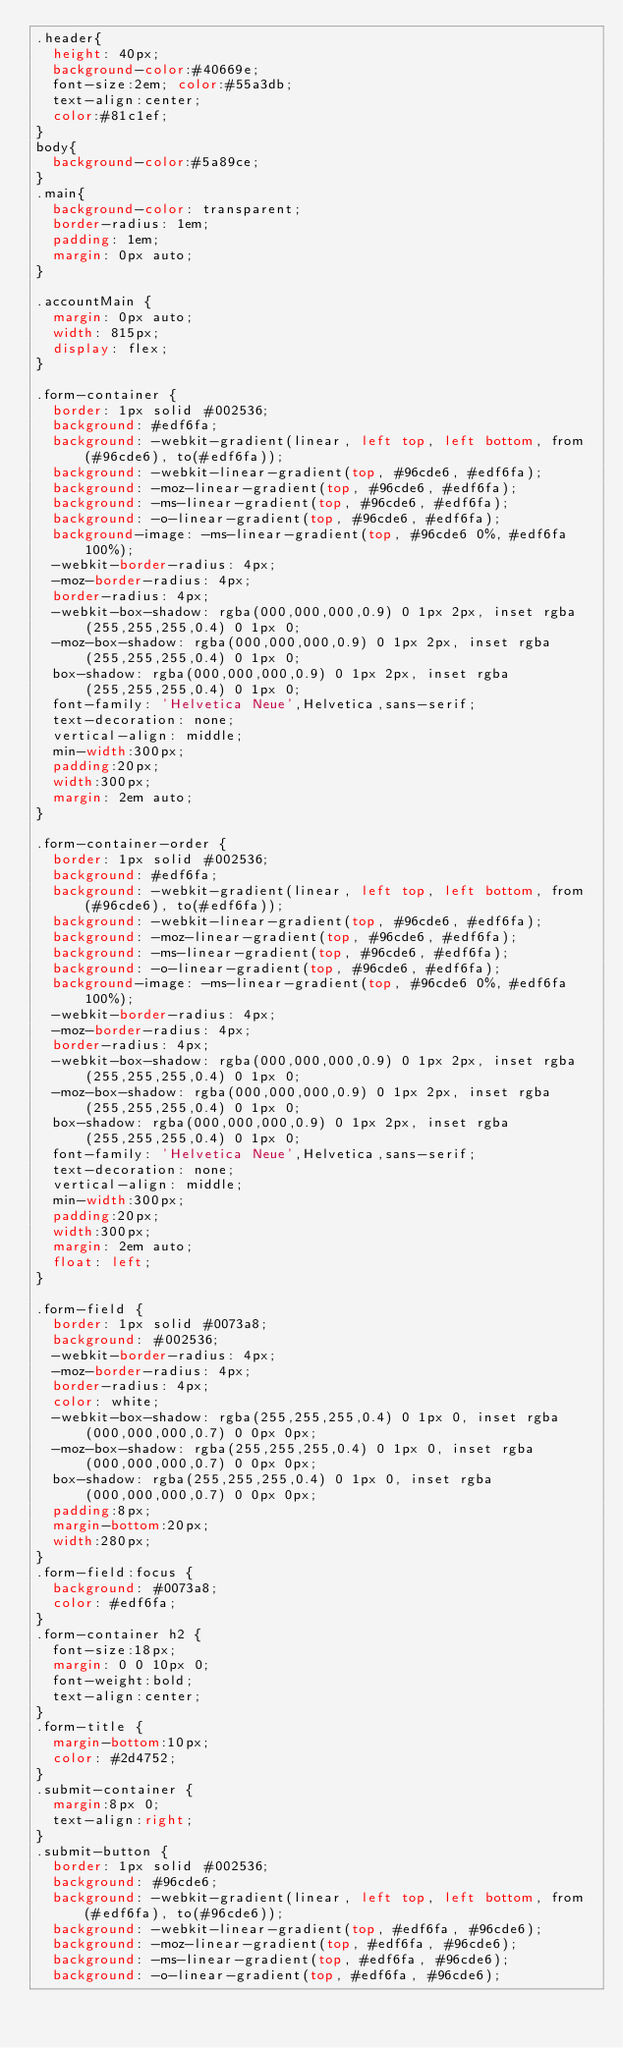<code> <loc_0><loc_0><loc_500><loc_500><_CSS_>.header{
  height: 40px;
  background-color:#40669e;
  font-size:2em; color:#55a3db;
  text-align:center;
  color:#81c1ef;
}
body{
  background-color:#5a89ce;
}
.main{
  background-color: transparent;
  border-radius: 1em;
  padding: 1em;
  margin: 0px auto;
}

.accountMain {
  margin: 0px auto;
  width: 815px;
  display: flex;
}

.form-container {
  border: 1px solid #002536;
  background: #edf6fa;
  background: -webkit-gradient(linear, left top, left bottom, from(#96cde6), to(#edf6fa));
  background: -webkit-linear-gradient(top, #96cde6, #edf6fa);
  background: -moz-linear-gradient(top, #96cde6, #edf6fa);
  background: -ms-linear-gradient(top, #96cde6, #edf6fa);
  background: -o-linear-gradient(top, #96cde6, #edf6fa);
  background-image: -ms-linear-gradient(top, #96cde6 0%, #edf6fa 100%);
  -webkit-border-radius: 4px;
  -moz-border-radius: 4px;
  border-radius: 4px;
  -webkit-box-shadow: rgba(000,000,000,0.9) 0 1px 2px, inset rgba(255,255,255,0.4) 0 1px 0;
  -moz-box-shadow: rgba(000,000,000,0.9) 0 1px 2px, inset rgba(255,255,255,0.4) 0 1px 0;
  box-shadow: rgba(000,000,000,0.9) 0 1px 2px, inset rgba(255,255,255,0.4) 0 1px 0;
  font-family: 'Helvetica Neue',Helvetica,sans-serif;
  text-decoration: none;
  vertical-align: middle;
  min-width:300px;
  padding:20px;
  width:300px;
  margin: 2em auto;
}

.form-container-order {
  border: 1px solid #002536;
  background: #edf6fa;
  background: -webkit-gradient(linear, left top, left bottom, from(#96cde6), to(#edf6fa));
  background: -webkit-linear-gradient(top, #96cde6, #edf6fa);
  background: -moz-linear-gradient(top, #96cde6, #edf6fa);
  background: -ms-linear-gradient(top, #96cde6, #edf6fa);
  background: -o-linear-gradient(top, #96cde6, #edf6fa);
  background-image: -ms-linear-gradient(top, #96cde6 0%, #edf6fa 100%);
  -webkit-border-radius: 4px;
  -moz-border-radius: 4px;
  border-radius: 4px;
  -webkit-box-shadow: rgba(000,000,000,0.9) 0 1px 2px, inset rgba(255,255,255,0.4) 0 1px 0;
  -moz-box-shadow: rgba(000,000,000,0.9) 0 1px 2px, inset rgba(255,255,255,0.4) 0 1px 0;
  box-shadow: rgba(000,000,000,0.9) 0 1px 2px, inset rgba(255,255,255,0.4) 0 1px 0;
  font-family: 'Helvetica Neue',Helvetica,sans-serif;
  text-decoration: none;
  vertical-align: middle;
  min-width:300px;
  padding:20px;
  width:300px;
  margin: 2em auto;
  float: left;
}

.form-field {
  border: 1px solid #0073a8;
  background: #002536;
  -webkit-border-radius: 4px;
  -moz-border-radius: 4px;
  border-radius: 4px;
  color: white;
  -webkit-box-shadow: rgba(255,255,255,0.4) 0 1px 0, inset rgba(000,000,000,0.7) 0 0px 0px;
  -moz-box-shadow: rgba(255,255,255,0.4) 0 1px 0, inset rgba(000,000,000,0.7) 0 0px 0px;
  box-shadow: rgba(255,255,255,0.4) 0 1px 0, inset rgba(000,000,000,0.7) 0 0px 0px;
  padding:8px;
  margin-bottom:20px;
  width:280px;
}
.form-field:focus {
  background: #0073a8;
  color: #edf6fa;
}
.form-container h2 {
  font-size:18px;
  margin: 0 0 10px 0;
  font-weight:bold;
  text-align:center;
}
.form-title {
  margin-bottom:10px;
  color: #2d4752;
}
.submit-container {
  margin:8px 0;
  text-align:right;
}
.submit-button {
  border: 1px solid #002536;
  background: #96cde6;
  background: -webkit-gradient(linear, left top, left bottom, from(#edf6fa), to(#96cde6));
  background: -webkit-linear-gradient(top, #edf6fa, #96cde6);
  background: -moz-linear-gradient(top, #edf6fa, #96cde6);
  background: -ms-linear-gradient(top, #edf6fa, #96cde6);
  background: -o-linear-gradient(top, #edf6fa, #96cde6);</code> 